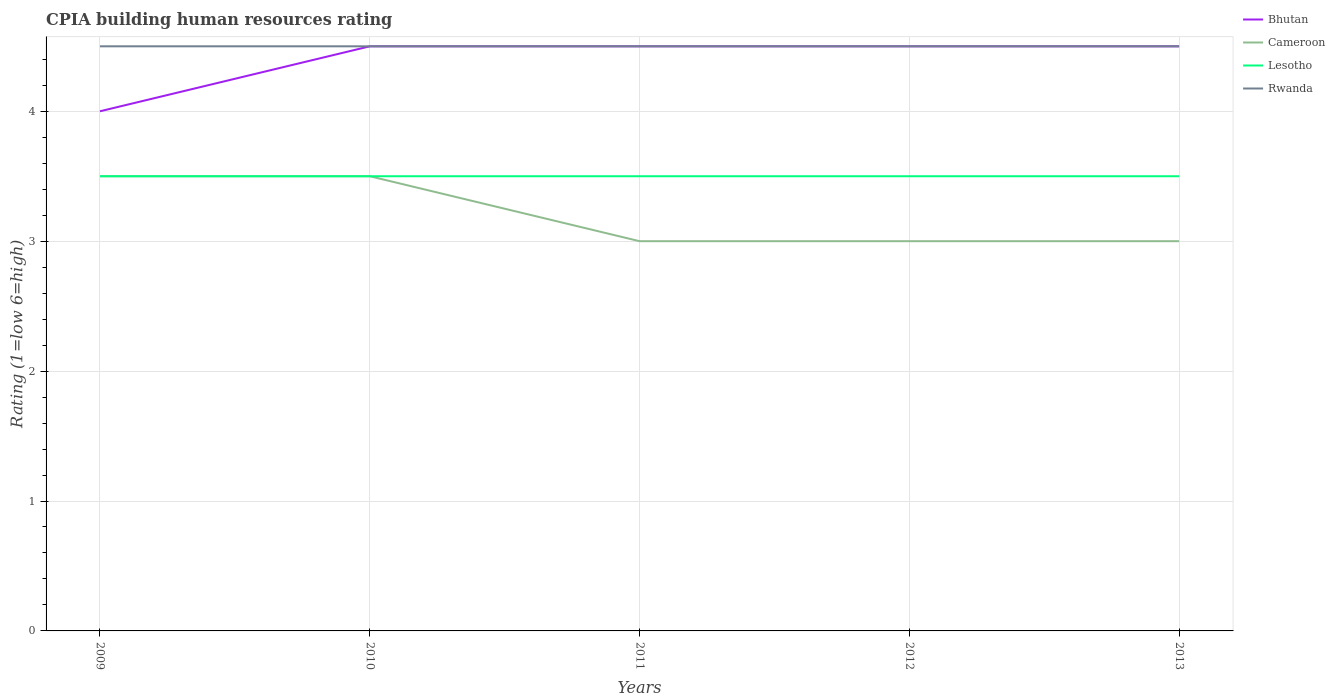What is the difference between the highest and the second highest CPIA rating in Bhutan?
Keep it short and to the point. 0.5. Is the CPIA rating in Cameroon strictly greater than the CPIA rating in Bhutan over the years?
Provide a short and direct response. Yes. What is the difference between two consecutive major ticks on the Y-axis?
Keep it short and to the point. 1. How many legend labels are there?
Keep it short and to the point. 4. How are the legend labels stacked?
Provide a succinct answer. Vertical. What is the title of the graph?
Make the answer very short. CPIA building human resources rating. What is the Rating (1=low 6=high) in Lesotho in 2009?
Make the answer very short. 3.5. What is the Rating (1=low 6=high) of Bhutan in 2010?
Make the answer very short. 4.5. What is the Rating (1=low 6=high) in Cameroon in 2010?
Make the answer very short. 3.5. What is the Rating (1=low 6=high) in Lesotho in 2011?
Your answer should be compact. 3.5. What is the Rating (1=low 6=high) in Rwanda in 2011?
Ensure brevity in your answer.  4.5. What is the Rating (1=low 6=high) of Lesotho in 2012?
Provide a succinct answer. 3.5. What is the Rating (1=low 6=high) of Rwanda in 2012?
Your answer should be compact. 4.5. What is the Rating (1=low 6=high) in Lesotho in 2013?
Your response must be concise. 3.5. Across all years, what is the maximum Rating (1=low 6=high) of Cameroon?
Your response must be concise. 3.5. Across all years, what is the maximum Rating (1=low 6=high) of Lesotho?
Make the answer very short. 3.5. Across all years, what is the maximum Rating (1=low 6=high) in Rwanda?
Offer a very short reply. 4.5. Across all years, what is the minimum Rating (1=low 6=high) of Rwanda?
Offer a terse response. 4.5. What is the difference between the Rating (1=low 6=high) in Bhutan in 2009 and that in 2010?
Provide a succinct answer. -0.5. What is the difference between the Rating (1=low 6=high) of Rwanda in 2009 and that in 2010?
Offer a terse response. 0. What is the difference between the Rating (1=low 6=high) of Rwanda in 2009 and that in 2011?
Provide a succinct answer. 0. What is the difference between the Rating (1=low 6=high) of Cameroon in 2009 and that in 2012?
Your response must be concise. 0.5. What is the difference between the Rating (1=low 6=high) of Bhutan in 2009 and that in 2013?
Ensure brevity in your answer.  -0.5. What is the difference between the Rating (1=low 6=high) of Cameroon in 2009 and that in 2013?
Your answer should be very brief. 0.5. What is the difference between the Rating (1=low 6=high) in Cameroon in 2010 and that in 2011?
Offer a terse response. 0.5. What is the difference between the Rating (1=low 6=high) of Lesotho in 2010 and that in 2011?
Keep it short and to the point. 0. What is the difference between the Rating (1=low 6=high) in Rwanda in 2010 and that in 2012?
Make the answer very short. 0. What is the difference between the Rating (1=low 6=high) in Cameroon in 2010 and that in 2013?
Your answer should be compact. 0.5. What is the difference between the Rating (1=low 6=high) in Lesotho in 2010 and that in 2013?
Make the answer very short. 0. What is the difference between the Rating (1=low 6=high) in Rwanda in 2010 and that in 2013?
Ensure brevity in your answer.  0. What is the difference between the Rating (1=low 6=high) in Bhutan in 2011 and that in 2012?
Your response must be concise. 0. What is the difference between the Rating (1=low 6=high) in Lesotho in 2011 and that in 2012?
Offer a terse response. 0. What is the difference between the Rating (1=low 6=high) of Bhutan in 2011 and that in 2013?
Your answer should be very brief. 0. What is the difference between the Rating (1=low 6=high) of Cameroon in 2011 and that in 2013?
Your response must be concise. 0. What is the difference between the Rating (1=low 6=high) of Rwanda in 2011 and that in 2013?
Your answer should be compact. 0. What is the difference between the Rating (1=low 6=high) in Cameroon in 2009 and the Rating (1=low 6=high) in Lesotho in 2010?
Provide a short and direct response. 0. What is the difference between the Rating (1=low 6=high) in Bhutan in 2009 and the Rating (1=low 6=high) in Cameroon in 2011?
Provide a short and direct response. 1. What is the difference between the Rating (1=low 6=high) in Bhutan in 2009 and the Rating (1=low 6=high) in Rwanda in 2011?
Make the answer very short. -0.5. What is the difference between the Rating (1=low 6=high) of Cameroon in 2009 and the Rating (1=low 6=high) of Lesotho in 2011?
Provide a short and direct response. 0. What is the difference between the Rating (1=low 6=high) in Lesotho in 2009 and the Rating (1=low 6=high) in Rwanda in 2011?
Your response must be concise. -1. What is the difference between the Rating (1=low 6=high) in Bhutan in 2009 and the Rating (1=low 6=high) in Cameroon in 2012?
Offer a terse response. 1. What is the difference between the Rating (1=low 6=high) of Bhutan in 2009 and the Rating (1=low 6=high) of Lesotho in 2012?
Your response must be concise. 0.5. What is the difference between the Rating (1=low 6=high) in Cameroon in 2009 and the Rating (1=low 6=high) in Lesotho in 2012?
Your answer should be compact. 0. What is the difference between the Rating (1=low 6=high) of Cameroon in 2009 and the Rating (1=low 6=high) of Rwanda in 2012?
Provide a short and direct response. -1. What is the difference between the Rating (1=low 6=high) of Bhutan in 2009 and the Rating (1=low 6=high) of Cameroon in 2013?
Provide a succinct answer. 1. What is the difference between the Rating (1=low 6=high) of Bhutan in 2009 and the Rating (1=low 6=high) of Lesotho in 2013?
Give a very brief answer. 0.5. What is the difference between the Rating (1=low 6=high) of Cameroon in 2009 and the Rating (1=low 6=high) of Lesotho in 2013?
Make the answer very short. 0. What is the difference between the Rating (1=low 6=high) of Cameroon in 2009 and the Rating (1=low 6=high) of Rwanda in 2013?
Offer a very short reply. -1. What is the difference between the Rating (1=low 6=high) of Lesotho in 2009 and the Rating (1=low 6=high) of Rwanda in 2013?
Ensure brevity in your answer.  -1. What is the difference between the Rating (1=low 6=high) of Bhutan in 2010 and the Rating (1=low 6=high) of Lesotho in 2011?
Keep it short and to the point. 1. What is the difference between the Rating (1=low 6=high) in Cameroon in 2010 and the Rating (1=low 6=high) in Lesotho in 2011?
Your answer should be compact. 0. What is the difference between the Rating (1=low 6=high) of Bhutan in 2010 and the Rating (1=low 6=high) of Rwanda in 2012?
Make the answer very short. 0. What is the difference between the Rating (1=low 6=high) of Cameroon in 2010 and the Rating (1=low 6=high) of Lesotho in 2012?
Your answer should be very brief. 0. What is the difference between the Rating (1=low 6=high) in Bhutan in 2010 and the Rating (1=low 6=high) in Lesotho in 2013?
Make the answer very short. 1. What is the difference between the Rating (1=low 6=high) of Bhutan in 2010 and the Rating (1=low 6=high) of Rwanda in 2013?
Offer a very short reply. 0. What is the difference between the Rating (1=low 6=high) of Cameroon in 2010 and the Rating (1=low 6=high) of Lesotho in 2013?
Your answer should be very brief. 0. What is the difference between the Rating (1=low 6=high) in Lesotho in 2010 and the Rating (1=low 6=high) in Rwanda in 2013?
Provide a succinct answer. -1. What is the difference between the Rating (1=low 6=high) in Bhutan in 2011 and the Rating (1=low 6=high) in Lesotho in 2012?
Ensure brevity in your answer.  1. What is the difference between the Rating (1=low 6=high) of Bhutan in 2011 and the Rating (1=low 6=high) of Rwanda in 2012?
Your response must be concise. 0. What is the difference between the Rating (1=low 6=high) in Cameroon in 2011 and the Rating (1=low 6=high) in Rwanda in 2012?
Provide a succinct answer. -1.5. What is the difference between the Rating (1=low 6=high) of Cameroon in 2011 and the Rating (1=low 6=high) of Lesotho in 2013?
Your answer should be very brief. -0.5. What is the difference between the Rating (1=low 6=high) in Cameroon in 2011 and the Rating (1=low 6=high) in Rwanda in 2013?
Your answer should be compact. -1.5. What is the difference between the Rating (1=low 6=high) of Bhutan in 2012 and the Rating (1=low 6=high) of Cameroon in 2013?
Ensure brevity in your answer.  1.5. What is the difference between the Rating (1=low 6=high) in Bhutan in 2012 and the Rating (1=low 6=high) in Rwanda in 2013?
Offer a very short reply. 0. What is the difference between the Rating (1=low 6=high) in Cameroon in 2012 and the Rating (1=low 6=high) in Lesotho in 2013?
Your answer should be compact. -0.5. What is the difference between the Rating (1=low 6=high) of Lesotho in 2012 and the Rating (1=low 6=high) of Rwanda in 2013?
Provide a short and direct response. -1. What is the average Rating (1=low 6=high) of Bhutan per year?
Your response must be concise. 4.4. What is the average Rating (1=low 6=high) of Rwanda per year?
Offer a very short reply. 4.5. In the year 2009, what is the difference between the Rating (1=low 6=high) in Bhutan and Rating (1=low 6=high) in Cameroon?
Your answer should be compact. 0.5. In the year 2009, what is the difference between the Rating (1=low 6=high) in Bhutan and Rating (1=low 6=high) in Lesotho?
Provide a succinct answer. 0.5. In the year 2009, what is the difference between the Rating (1=low 6=high) of Bhutan and Rating (1=low 6=high) of Rwanda?
Ensure brevity in your answer.  -0.5. In the year 2009, what is the difference between the Rating (1=low 6=high) of Cameroon and Rating (1=low 6=high) of Lesotho?
Provide a short and direct response. 0. In the year 2009, what is the difference between the Rating (1=low 6=high) of Lesotho and Rating (1=low 6=high) of Rwanda?
Make the answer very short. -1. In the year 2010, what is the difference between the Rating (1=low 6=high) in Bhutan and Rating (1=low 6=high) in Rwanda?
Offer a terse response. 0. In the year 2010, what is the difference between the Rating (1=low 6=high) in Cameroon and Rating (1=low 6=high) in Lesotho?
Keep it short and to the point. 0. In the year 2010, what is the difference between the Rating (1=low 6=high) of Lesotho and Rating (1=low 6=high) of Rwanda?
Make the answer very short. -1. In the year 2011, what is the difference between the Rating (1=low 6=high) in Bhutan and Rating (1=low 6=high) in Cameroon?
Ensure brevity in your answer.  1.5. In the year 2011, what is the difference between the Rating (1=low 6=high) of Cameroon and Rating (1=low 6=high) of Lesotho?
Offer a very short reply. -0.5. In the year 2011, what is the difference between the Rating (1=low 6=high) of Lesotho and Rating (1=low 6=high) of Rwanda?
Provide a succinct answer. -1. In the year 2012, what is the difference between the Rating (1=low 6=high) of Bhutan and Rating (1=low 6=high) of Cameroon?
Your answer should be compact. 1.5. In the year 2012, what is the difference between the Rating (1=low 6=high) in Bhutan and Rating (1=low 6=high) in Lesotho?
Your answer should be very brief. 1. In the year 2012, what is the difference between the Rating (1=low 6=high) of Cameroon and Rating (1=low 6=high) of Rwanda?
Ensure brevity in your answer.  -1.5. In the year 2012, what is the difference between the Rating (1=low 6=high) of Lesotho and Rating (1=low 6=high) of Rwanda?
Keep it short and to the point. -1. In the year 2013, what is the difference between the Rating (1=low 6=high) in Bhutan and Rating (1=low 6=high) in Lesotho?
Keep it short and to the point. 1. In the year 2013, what is the difference between the Rating (1=low 6=high) of Bhutan and Rating (1=low 6=high) of Rwanda?
Keep it short and to the point. 0. What is the ratio of the Rating (1=low 6=high) of Bhutan in 2009 to that in 2010?
Your answer should be compact. 0.89. What is the ratio of the Rating (1=low 6=high) in Cameroon in 2009 to that in 2010?
Ensure brevity in your answer.  1. What is the ratio of the Rating (1=low 6=high) in Bhutan in 2009 to that in 2011?
Provide a short and direct response. 0.89. What is the ratio of the Rating (1=low 6=high) of Rwanda in 2009 to that in 2011?
Your answer should be compact. 1. What is the ratio of the Rating (1=low 6=high) of Lesotho in 2009 to that in 2012?
Offer a terse response. 1. What is the ratio of the Rating (1=low 6=high) of Rwanda in 2009 to that in 2013?
Offer a terse response. 1. What is the ratio of the Rating (1=low 6=high) in Bhutan in 2010 to that in 2011?
Provide a succinct answer. 1. What is the ratio of the Rating (1=low 6=high) in Cameroon in 2010 to that in 2011?
Offer a terse response. 1.17. What is the ratio of the Rating (1=low 6=high) in Lesotho in 2010 to that in 2011?
Give a very brief answer. 1. What is the ratio of the Rating (1=low 6=high) in Bhutan in 2010 to that in 2012?
Provide a succinct answer. 1. What is the ratio of the Rating (1=low 6=high) in Cameroon in 2010 to that in 2012?
Ensure brevity in your answer.  1.17. What is the ratio of the Rating (1=low 6=high) in Lesotho in 2010 to that in 2012?
Keep it short and to the point. 1. What is the ratio of the Rating (1=low 6=high) in Bhutan in 2010 to that in 2013?
Ensure brevity in your answer.  1. What is the ratio of the Rating (1=low 6=high) in Lesotho in 2010 to that in 2013?
Your response must be concise. 1. What is the ratio of the Rating (1=low 6=high) in Rwanda in 2010 to that in 2013?
Your response must be concise. 1. What is the ratio of the Rating (1=low 6=high) of Bhutan in 2011 to that in 2012?
Provide a succinct answer. 1. What is the ratio of the Rating (1=low 6=high) of Cameroon in 2011 to that in 2012?
Keep it short and to the point. 1. What is the ratio of the Rating (1=low 6=high) of Lesotho in 2011 to that in 2012?
Make the answer very short. 1. What is the ratio of the Rating (1=low 6=high) of Rwanda in 2011 to that in 2012?
Provide a succinct answer. 1. What is the ratio of the Rating (1=low 6=high) in Cameroon in 2011 to that in 2013?
Your answer should be very brief. 1. What is the ratio of the Rating (1=low 6=high) in Rwanda in 2011 to that in 2013?
Offer a terse response. 1. What is the ratio of the Rating (1=low 6=high) of Lesotho in 2012 to that in 2013?
Your answer should be compact. 1. What is the difference between the highest and the second highest Rating (1=low 6=high) in Bhutan?
Ensure brevity in your answer.  0. What is the difference between the highest and the second highest Rating (1=low 6=high) of Cameroon?
Keep it short and to the point. 0. What is the difference between the highest and the second highest Rating (1=low 6=high) in Lesotho?
Your response must be concise. 0. What is the difference between the highest and the second highest Rating (1=low 6=high) of Rwanda?
Ensure brevity in your answer.  0. 